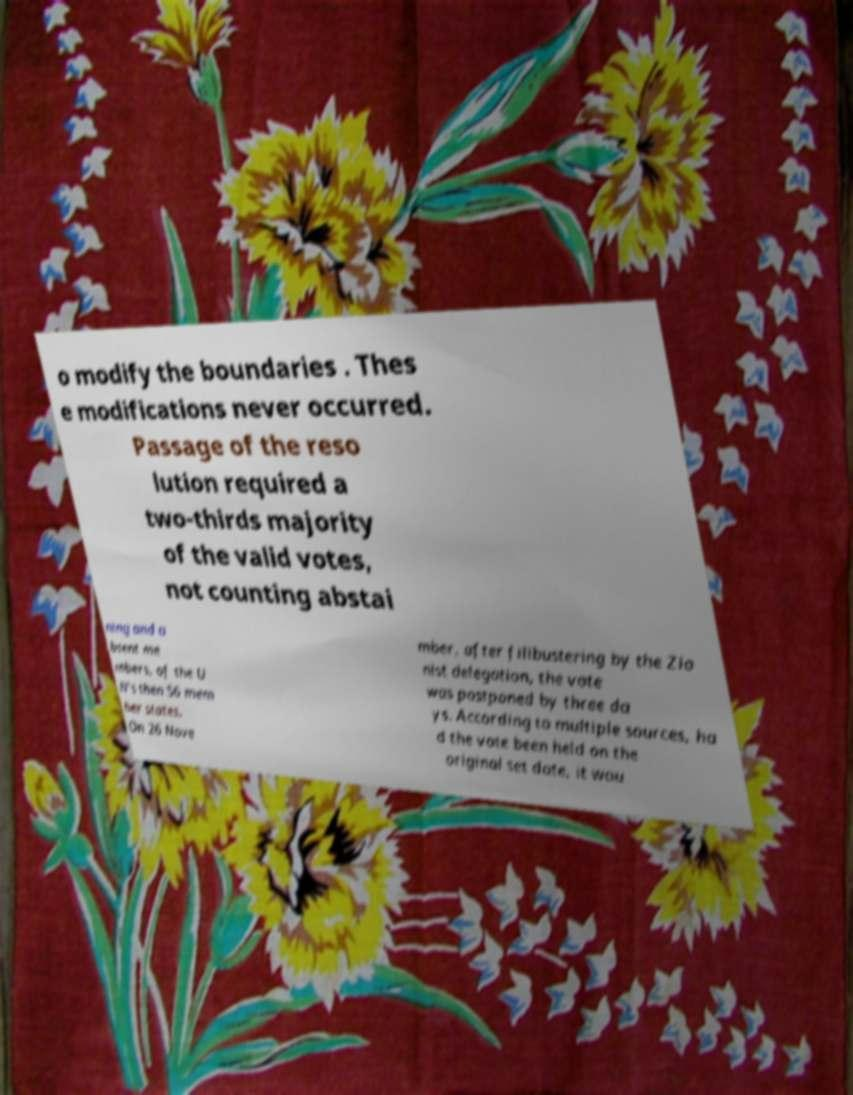For documentation purposes, I need the text within this image transcribed. Could you provide that? o modify the boundaries . Thes e modifications never occurred. Passage of the reso lution required a two-thirds majority of the valid votes, not counting abstai ning and a bsent me mbers, of the U N's then 56 mem ber states. On 26 Nove mber, after filibustering by the Zio nist delegation, the vote was postponed by three da ys. According to multiple sources, ha d the vote been held on the original set date, it wou 